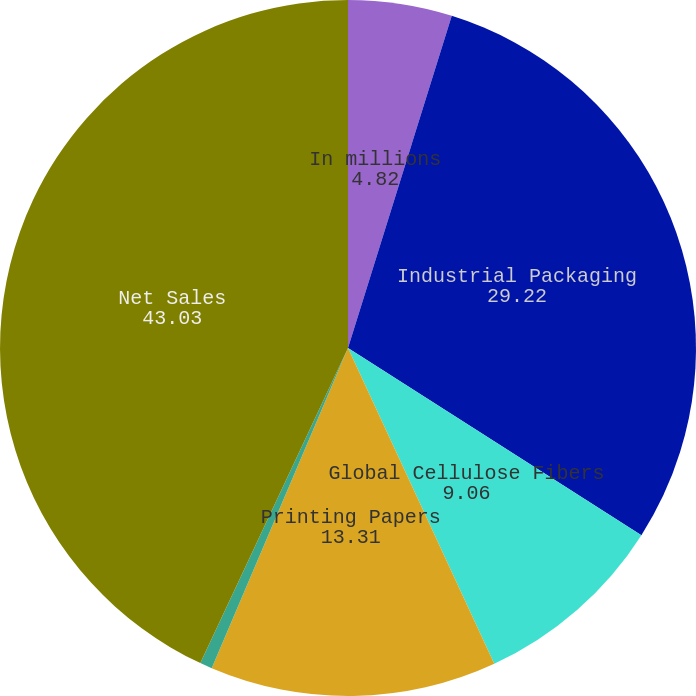Convert chart. <chart><loc_0><loc_0><loc_500><loc_500><pie_chart><fcel>In millions<fcel>Industrial Packaging<fcel>Global Cellulose Fibers<fcel>Printing Papers<fcel>Other (i)<fcel>Net Sales<nl><fcel>4.82%<fcel>29.22%<fcel>9.06%<fcel>13.31%<fcel>0.57%<fcel>43.03%<nl></chart> 